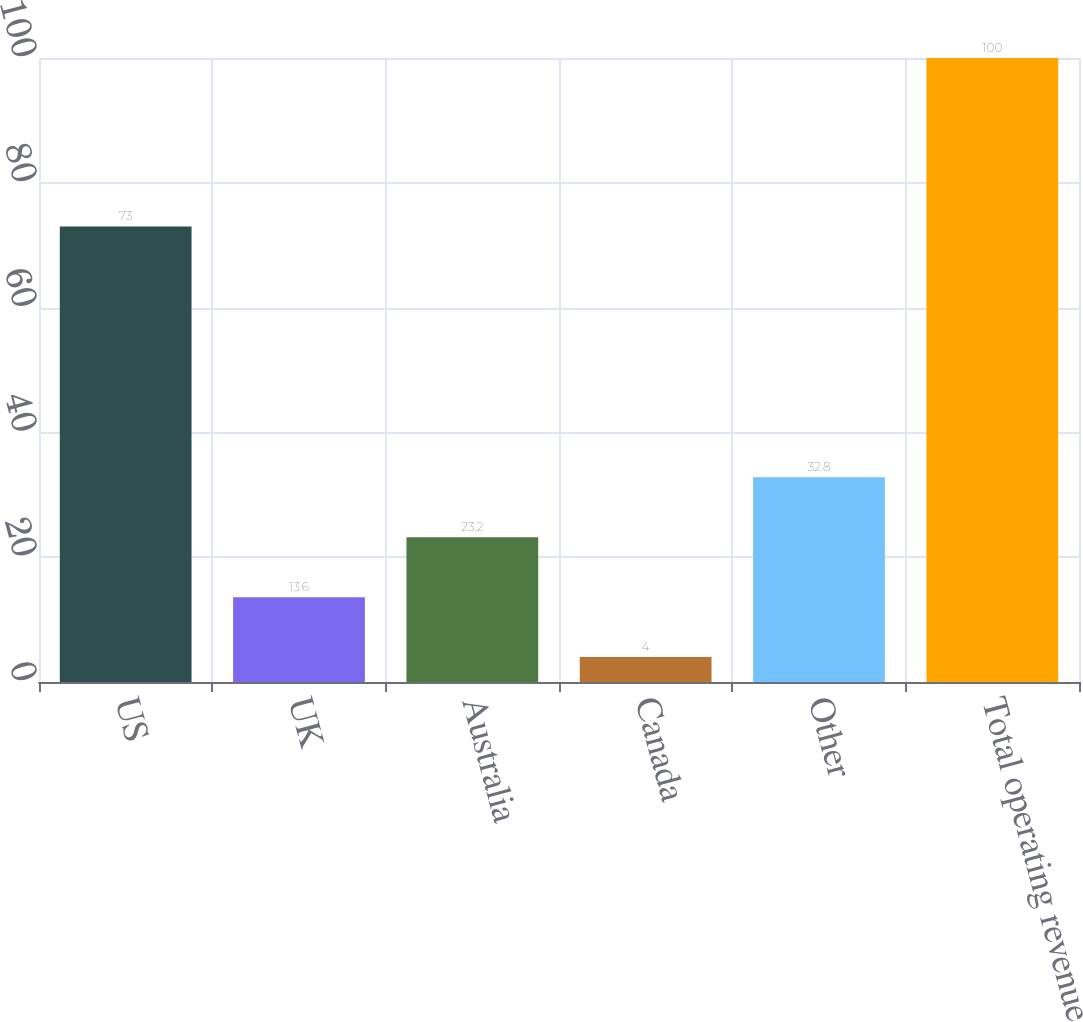Convert chart. <chart><loc_0><loc_0><loc_500><loc_500><bar_chart><fcel>US<fcel>UK<fcel>Australia<fcel>Canada<fcel>Other<fcel>Total operating revenue<nl><fcel>73<fcel>13.6<fcel>23.2<fcel>4<fcel>32.8<fcel>100<nl></chart> 